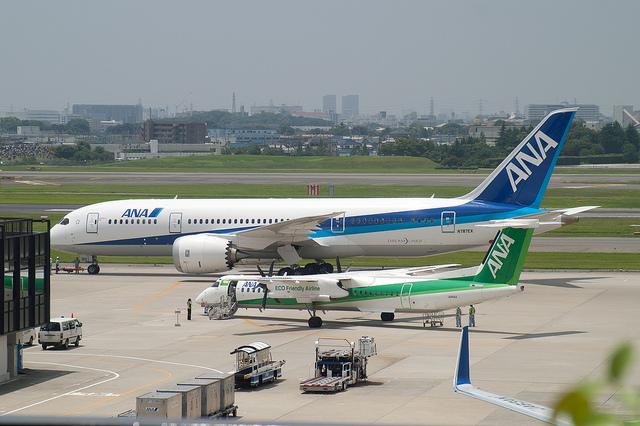What airline is this?
Short answer required. Ana. How many planes are on the ground?
Give a very brief answer. 2. What is the speed of this airplane?
Concise answer only. 0. Is the green plane under the blue one?
Answer briefly. No. 